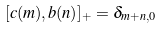<formula> <loc_0><loc_0><loc_500><loc_500>[ c ( m ) , b ( n ) ] _ { + } = \delta _ { m + n , 0 }</formula> 